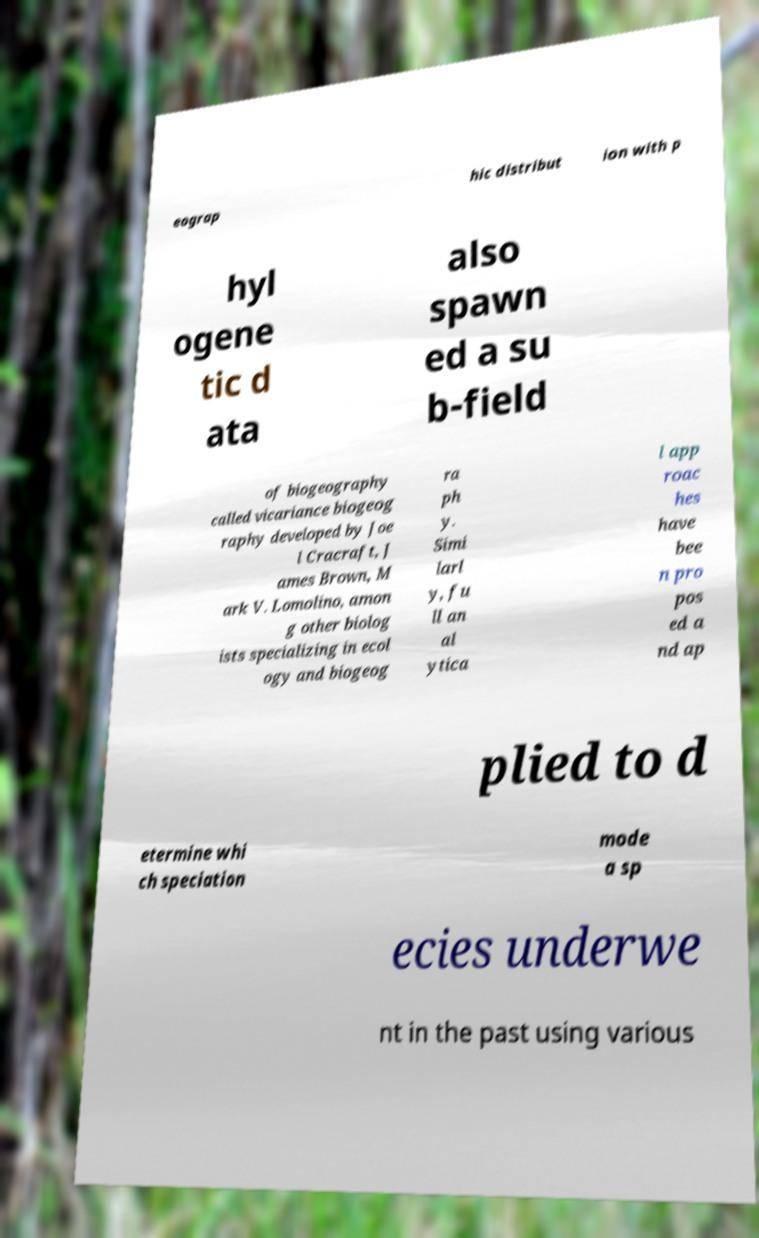Could you assist in decoding the text presented in this image and type it out clearly? eograp hic distribut ion with p hyl ogene tic d ata also spawn ed a su b-field of biogeography called vicariance biogeog raphy developed by Joe l Cracraft, J ames Brown, M ark V. Lomolino, amon g other biolog ists specializing in ecol ogy and biogeog ra ph y. Simi larl y, fu ll an al ytica l app roac hes have bee n pro pos ed a nd ap plied to d etermine whi ch speciation mode a sp ecies underwe nt in the past using various 